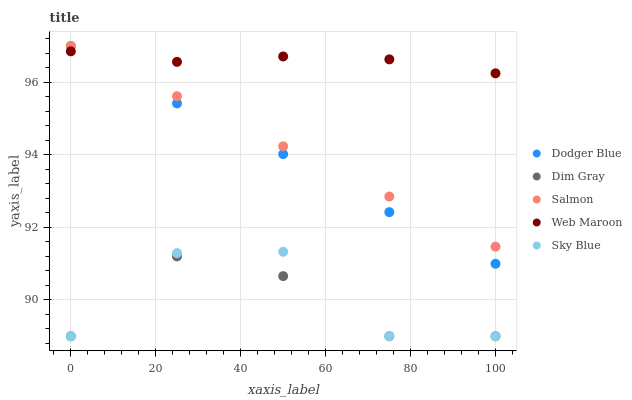Does Dim Gray have the minimum area under the curve?
Answer yes or no. Yes. Does Web Maroon have the maximum area under the curve?
Answer yes or no. Yes. Does Dodger Blue have the minimum area under the curve?
Answer yes or no. No. Does Dodger Blue have the maximum area under the curve?
Answer yes or no. No. Is Salmon the smoothest?
Answer yes or no. Yes. Is Sky Blue the roughest?
Answer yes or no. Yes. Is Dim Gray the smoothest?
Answer yes or no. No. Is Dim Gray the roughest?
Answer yes or no. No. Does Dim Gray have the lowest value?
Answer yes or no. Yes. Does Dodger Blue have the lowest value?
Answer yes or no. No. Does Dodger Blue have the highest value?
Answer yes or no. Yes. Does Dim Gray have the highest value?
Answer yes or no. No. Is Sky Blue less than Dodger Blue?
Answer yes or no. Yes. Is Dodger Blue greater than Sky Blue?
Answer yes or no. Yes. Does Web Maroon intersect Dodger Blue?
Answer yes or no. Yes. Is Web Maroon less than Dodger Blue?
Answer yes or no. No. Is Web Maroon greater than Dodger Blue?
Answer yes or no. No. Does Sky Blue intersect Dodger Blue?
Answer yes or no. No. 